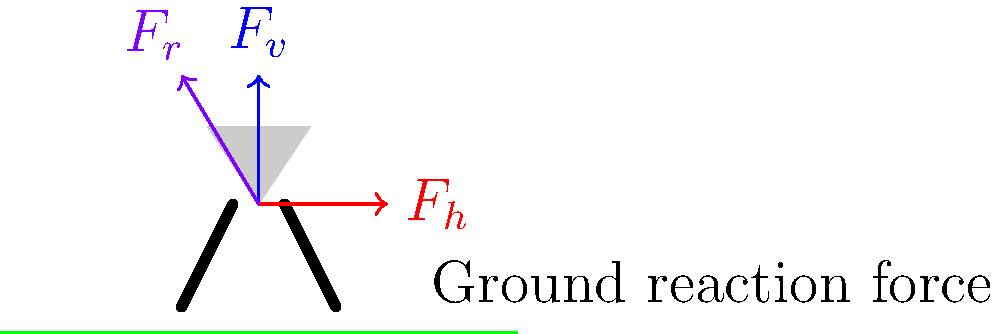In the biomechanics of a kangaroo's hop, which force vector represents the primary propulsive force that drives the kangaroo forward, and what is its relationship to the other forces shown in the diagram? To understand the biomechanics of a kangaroo's hop, let's analyze the force vectors in the diagram:

1. $F_v$ (blue vector): This represents the vertical force component, which helps the kangaroo overcome gravity and achieve height in its hop.

2. $F_h$ (red vector): This is the horizontal force component, which propels the kangaroo forward.

3. $F_r$ (purple vector): This is the resultant force, which is the combination of the vertical and horizontal forces.

The primary propulsive force that drives the kangaroo forward is the horizontal force ($F_h$). This force is generated by the powerful hind legs of the kangaroo as they push against the ground.

The relationship between these forces can be described as follows:

1. The resultant force ($F_r$) is the vector sum of the vertical ($F_v$) and horizontal ($F_h$) forces.
2. Mathematically, this relationship can be expressed using the Pythagorean theorem:

   $$F_r^2 = F_v^2 + F_h^2$$

3. The angle of the resultant force with respect to the horizontal can be calculated using trigonometry:

   $$\tan \theta = \frac{F_v}{F_h}$$

The horizontal force ($F_h$) is crucial for the kangaroo's forward motion. It's generated by the angled push of the hind legs against the ground, which converts some of the vertical force into forward momentum. This efficient locomotion method allows kangaroos to cover large distances with minimal energy expenditure.
Answer: $F_h$ (horizontal force); vector sum with $F_v$, forming resultant $F_r$ 